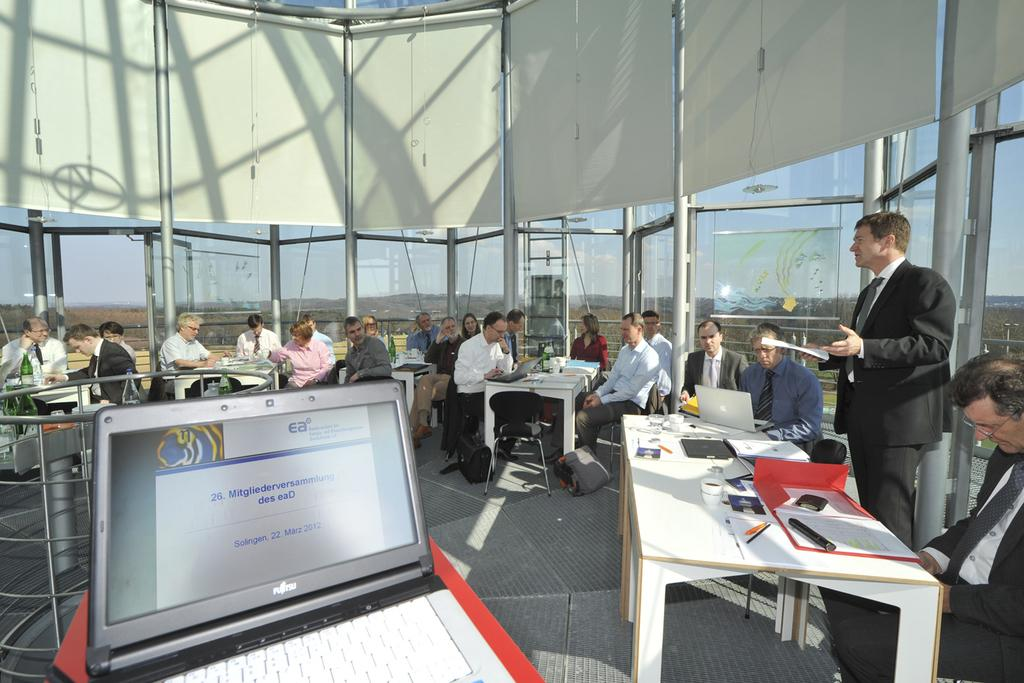What electronic device is visible in the image? There is a laptop in the image. What are the people behind the laptop doing? People are sitting behind the laptop. Can you describe the person standing on the left side of the image? The person standing is holding a paper in his hand. What does the laptop taste like in the image? Laptops do not have a taste, as they are electronic devices and not food items. 